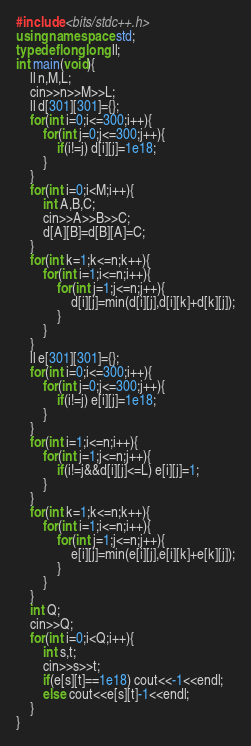Convert code to text. <code><loc_0><loc_0><loc_500><loc_500><_C++_>#include <bits/stdc++.h>
using namespace std;
typedef long long ll;
int main(void){
    ll n,M,L;
    cin>>n>>M>>L;
    ll d[301][301]={};
    for(int i=0;i<=300;i++){
        for(int j=0;j<=300;j++){
            if(i!=j) d[i][j]=1e18;
        }
    }
    for(int i=0;i<M;i++){
        int A,B,C;
        cin>>A>>B>>C;
        d[A][B]=d[B][A]=C;
    }
    for(int k=1;k<=n;k++){
        for(int i=1;i<=n;i++){
            for(int j=1;j<=n;j++){
                d[i][j]=min(d[i][j],d[i][k]+d[k][j]);
            }
        }
    }
    ll e[301][301]={};
    for(int i=0;i<=300;i++){
        for(int j=0;j<=300;j++){
            if(i!=j) e[i][j]=1e18;
        }
    }
    for(int i=1;i<=n;i++){
        for(int j=1;j<=n;j++){
            if(i!=j&&d[i][j]<=L) e[i][j]=1;
        }
    }
    for(int k=1;k<=n;k++){
        for(int i=1;i<=n;i++){
            for(int j=1;j<=n;j++){
                e[i][j]=min(e[i][j],e[i][k]+e[k][j]);
            }
        }
    }
    int Q;
    cin>>Q;
    for(int i=0;i<Q;i++){
        int s,t;
        cin>>s>>t;
        if(e[s][t]==1e18) cout<<-1<<endl;
        else cout<<e[s][t]-1<<endl;
    }
}</code> 